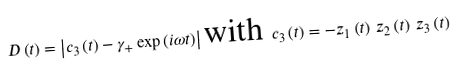Convert formula to latex. <formula><loc_0><loc_0><loc_500><loc_500>D \left ( t \right ) = \left | c _ { 3 } \left ( t \right ) - \gamma _ { + } \exp \left ( i \omega t \right ) \right | \text {with } c _ { 3 } \left ( t \right ) = - z _ { 1 } \left ( t \right ) \, z _ { 2 } \left ( t \right ) \, z _ { 3 } \left ( t \right )</formula> 